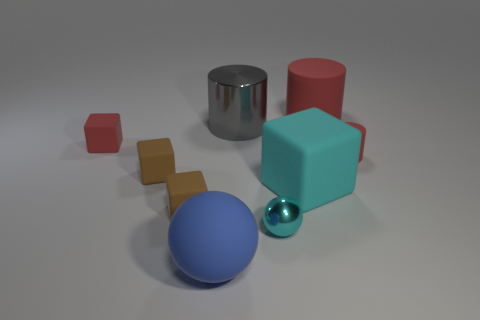Add 1 big blue rubber balls. How many objects exist? 10 Subtract all red spheres. Subtract all red cylinders. How many spheres are left? 2 Subtract all blocks. How many objects are left? 5 Add 5 big green cylinders. How many big green cylinders exist? 5 Subtract 1 red cubes. How many objects are left? 8 Subtract all tiny red rubber cylinders. Subtract all big red shiny cubes. How many objects are left? 8 Add 6 metallic balls. How many metallic balls are left? 7 